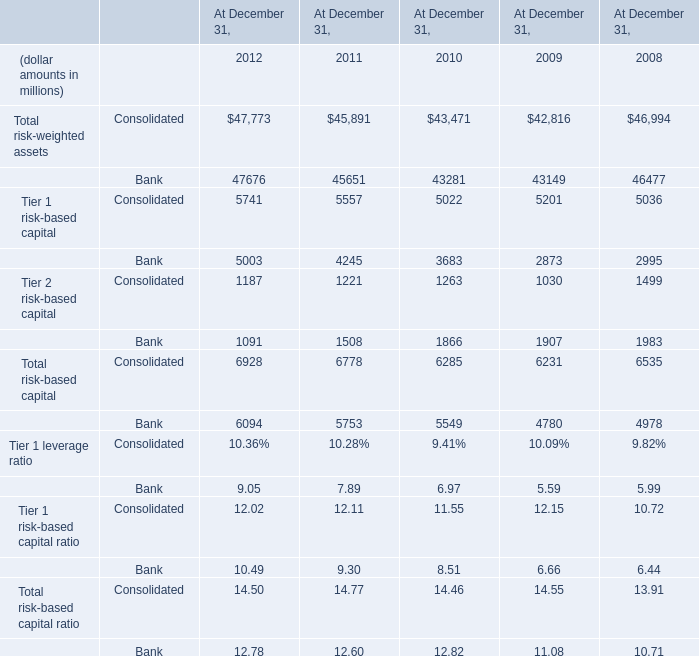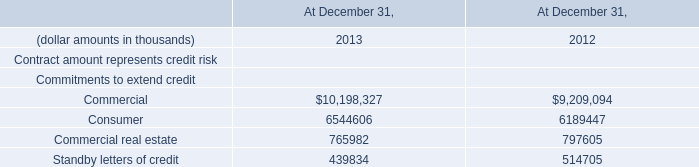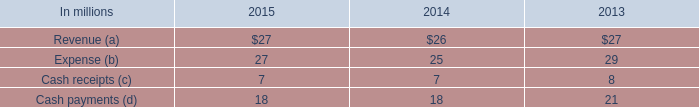At December 31,what year is the proportion of the Tier 2 risk-based capital in terms of Bank in relation to the Total risk-based capital in terms of Bank the greatest? 
Answer: 2009. 